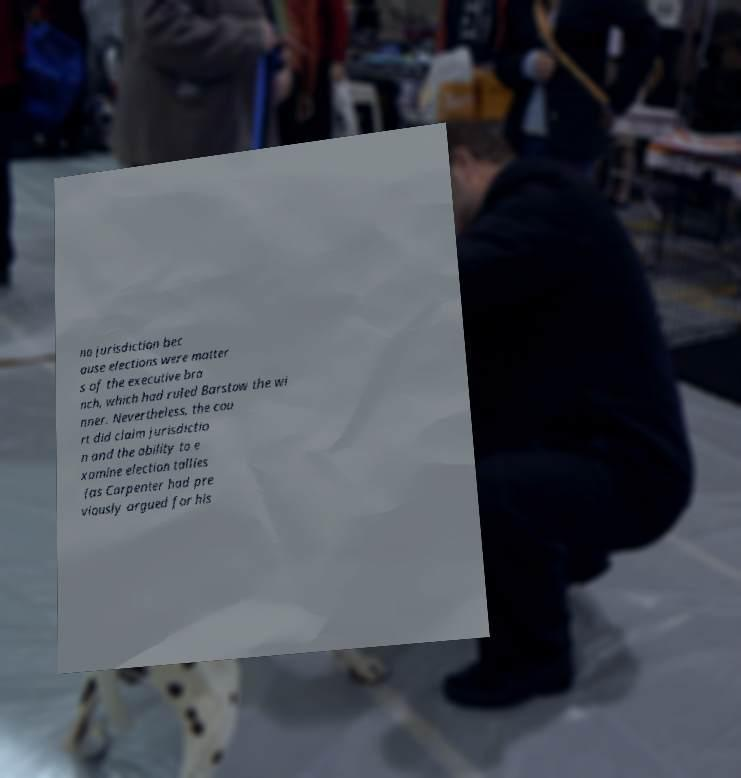For documentation purposes, I need the text within this image transcribed. Could you provide that? no jurisdiction bec ause elections were matter s of the executive bra nch, which had ruled Barstow the wi nner. Nevertheless, the cou rt did claim jurisdictio n and the ability to e xamine election tallies (as Carpenter had pre viously argued for his 